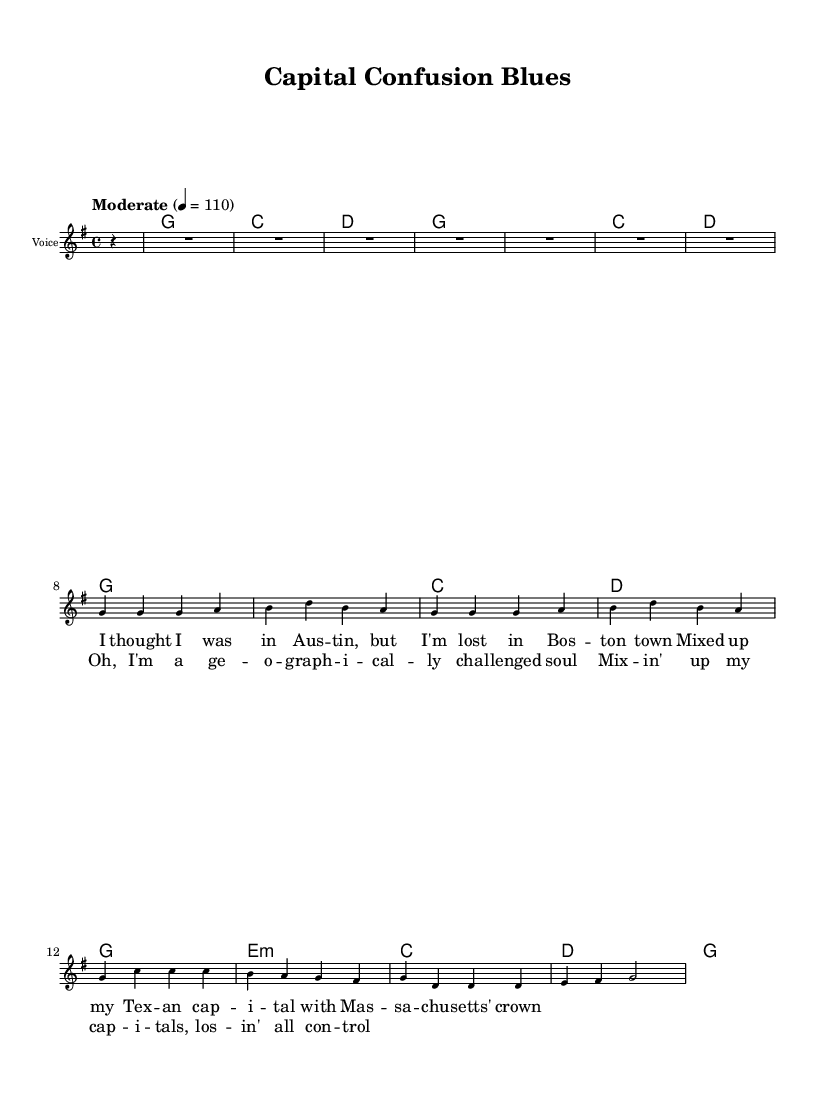What is the title of this music? The title of this sheet music is specified in the header section and it reads "Capital Confusion Blues".
Answer: Capital Confusion Blues What is the key signature of this music? The key signature is indicated at the beginning and shows that there are no sharps or flats, establishing G major as the key.
Answer: G major What is the time signature of this music? The time signature is shown at the start of the music, which is 4/4, meaning there are four beats in each measure.
Answer: 4/4 What is the tempo marking in this piece? The tempo marking indicates the speed of the music and specifies "Moderate" with a metronome marking of 110 beats per minute.
Answer: Moderate How many measures does the verse contain? Counting the measures in the verse, there are a total of 8 measures represented before the chorus begins.
Answer: 8 What is the overall theme of the lyrics in this song? The lyrics describe a person experiencing confusion over state capitals, indicating a humorous take on geographical mix-ups, hence reflecting the subject of the song.
Answer: Geographic confusion Which musical form does this piece follow? Analyzing the structure, the piece contains verses followed by a repeated chorus, characteristic of country rock's simple verse-chorus form.
Answer: Verse-chorus 